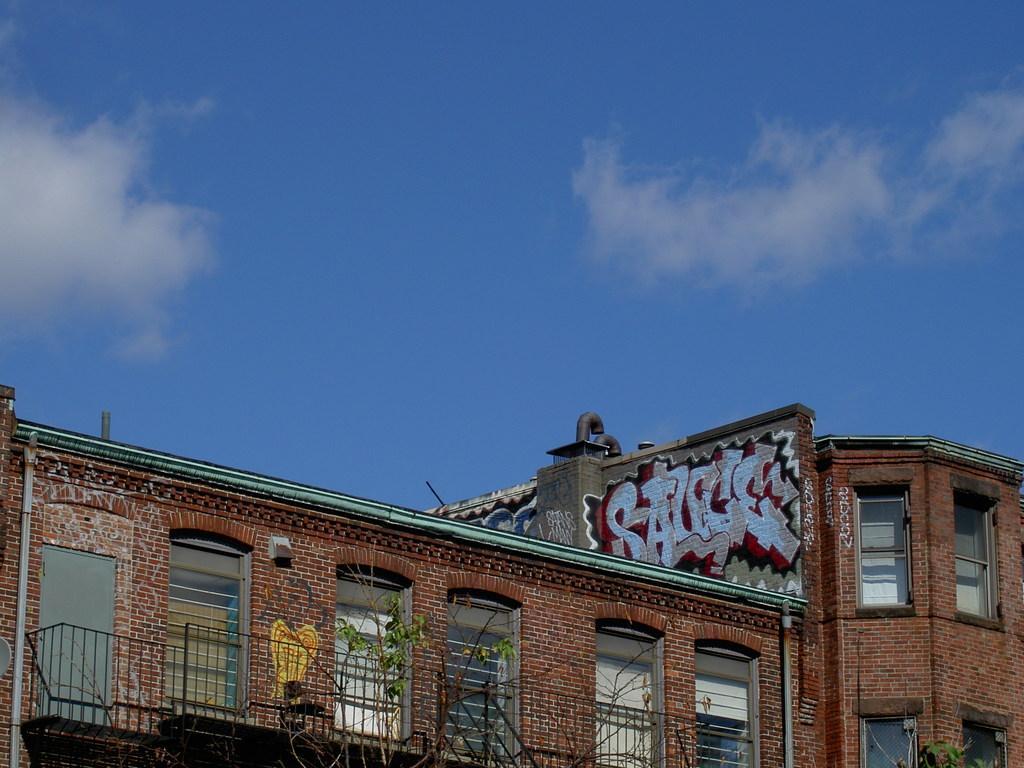Please provide a concise description of this image. We can see trees,building,windows and graffiti on a wall. In the background we can see sky with clouds. 